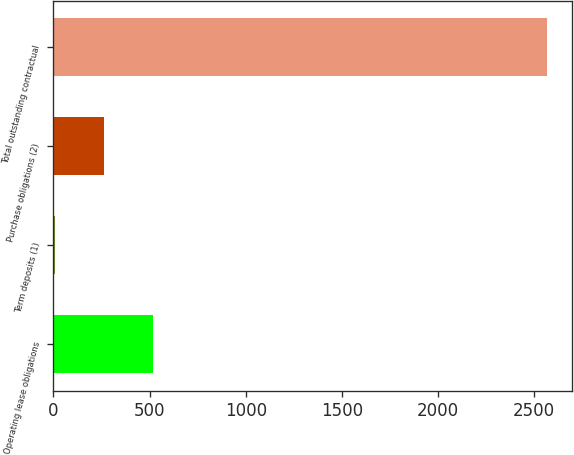Convert chart. <chart><loc_0><loc_0><loc_500><loc_500><bar_chart><fcel>Operating lease obligations<fcel>Term deposits (1)<fcel>Purchase obligations (2)<fcel>Total outstanding contractual<nl><fcel>519.2<fcel>7<fcel>263.1<fcel>2568<nl></chart> 